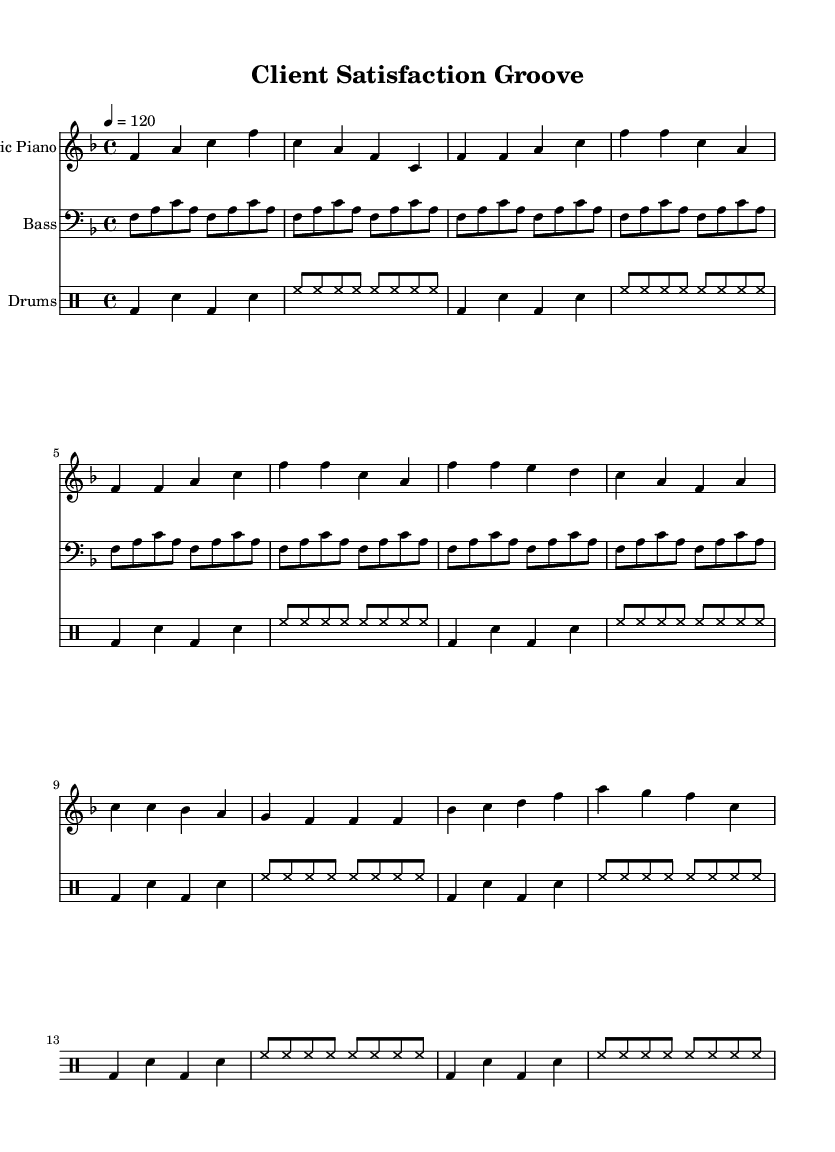What is the key signature of this music? The key signature indicates the key of F major, which has a single flat (B flat) shown in the key signature.
Answer: F major What is the time signature of this music? The time signature is expressed as a fraction at the beginning of the score, shown as 4/4, meaning there are four beats in each measure and the quarter note receives one beat.
Answer: 4/4 What is the tempo marking in this piece? The tempo marking is indicated at the start of the score by the number "120" which specifies the beats per minute, suggesting a moderately fast pace.
Answer: 120 How many measures are in the verse section? The verse section of the music consists of two lines, each containing four measures, totaling eight measures in the verse section.
Answer: 8 What is the main instrument for the melody? The main instrument for the melodic line is the electric piano, as it is notated in the treble clef and plays the lead part throughout the piece.
Answer: Electric Piano What rhythmic pattern do the drums follow? The drum pattern consists of a bass drum (bd), snare (sn), and hi-hats (hh), shown in the drum notation, which repeats over multiple measures creating a groove typical of Funky Soul music.
Answer: Funky groove Which section contains a bridge? The bridge is clearly labeled in structure and can be identified as a distinct section in the score that comes after the chorus, comprised of specific measures showcasing a change in harmony or rhythm.
Answer: Bridge 